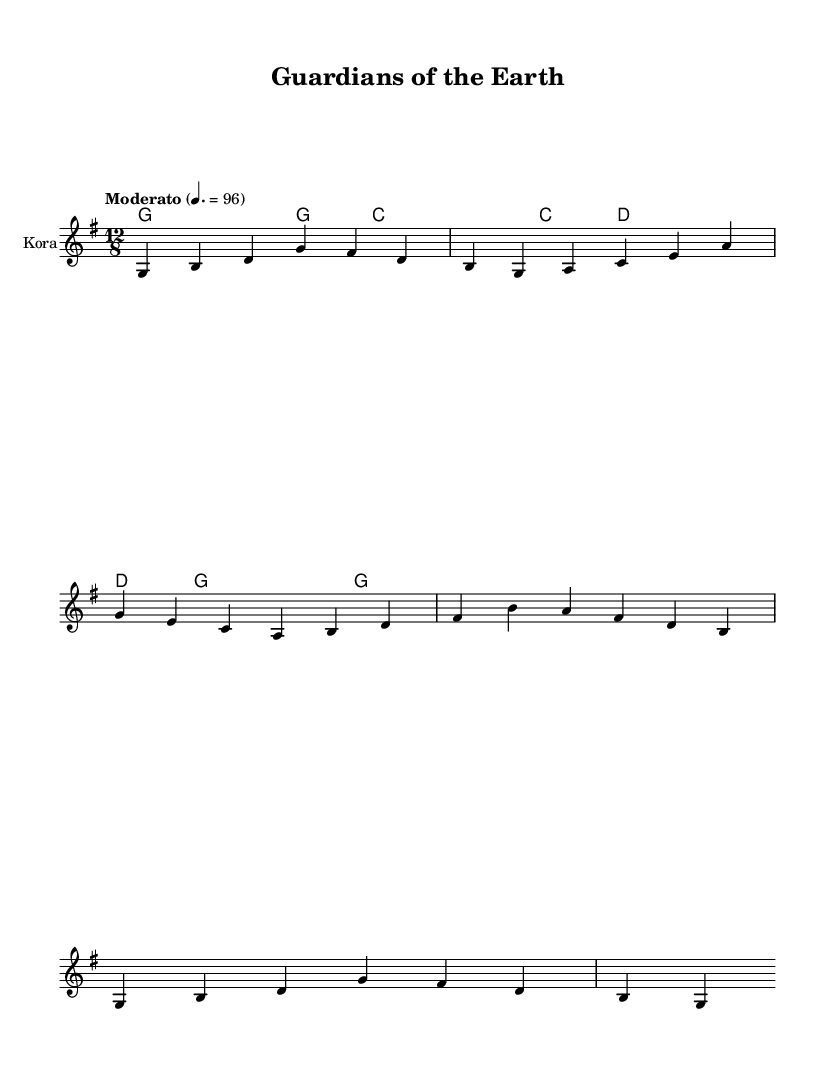What is the key signature of this music? The key signature is G major, which has one sharp (F#). This is determined by looking at the beginning of the sheet music where the key signature is indicated.
Answer: G major What is the time signature of this music? The time signature is 12/8, as indicated at the beginning of the score. This means there are 12 eighth notes in each measure.
Answer: 12/8 What is the tempo marking of the piece? The tempo marking is "Moderato" with a metronome marking of 96 beats per minute. This information is provided right below the time signature, indicating the speed of the music.
Answer: Moderato 96 How many measures are in the melody? The melody contains 4 measures, which can be counted on the score as there are 4 sets of vertical lines dividing the music into separate measures.
Answer: 4 What instrument is indicated for the performance? The indicated instrument for the performance is the "Kora," as stated in the instrument name at the start of the staff.
Answer: Kora What themes are explored in the lyrics? The themes explored in the lyrics include environmental stewardship, protection of nature, and the use of clean energy, which is conveyed through phrases about guardianship and a greener world.
Answer: Environmental stewardship What chord is played in the first measure? The chord played in the first measure is G major, as indicated by the chord notation shown above the staff in the first measure.
Answer: G major 